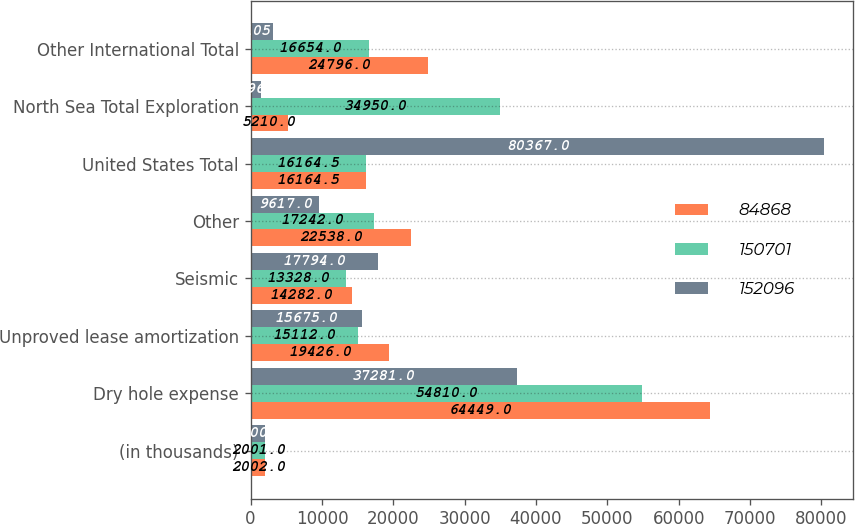Convert chart to OTSL. <chart><loc_0><loc_0><loc_500><loc_500><stacked_bar_chart><ecel><fcel>(in thousands)<fcel>Dry hole expense<fcel>Unproved lease amortization<fcel>Seismic<fcel>Other<fcel>United States Total<fcel>North Sea Total Exploration<fcel>Other International Total<nl><fcel>84868<fcel>2002<fcel>64449<fcel>19426<fcel>14282<fcel>22538<fcel>16164.5<fcel>5210<fcel>24796<nl><fcel>150701<fcel>2001<fcel>54810<fcel>15112<fcel>13328<fcel>17242<fcel>16164.5<fcel>34950<fcel>16654<nl><fcel>152096<fcel>2000<fcel>37281<fcel>15675<fcel>17794<fcel>9617<fcel>80367<fcel>1396<fcel>3105<nl></chart> 